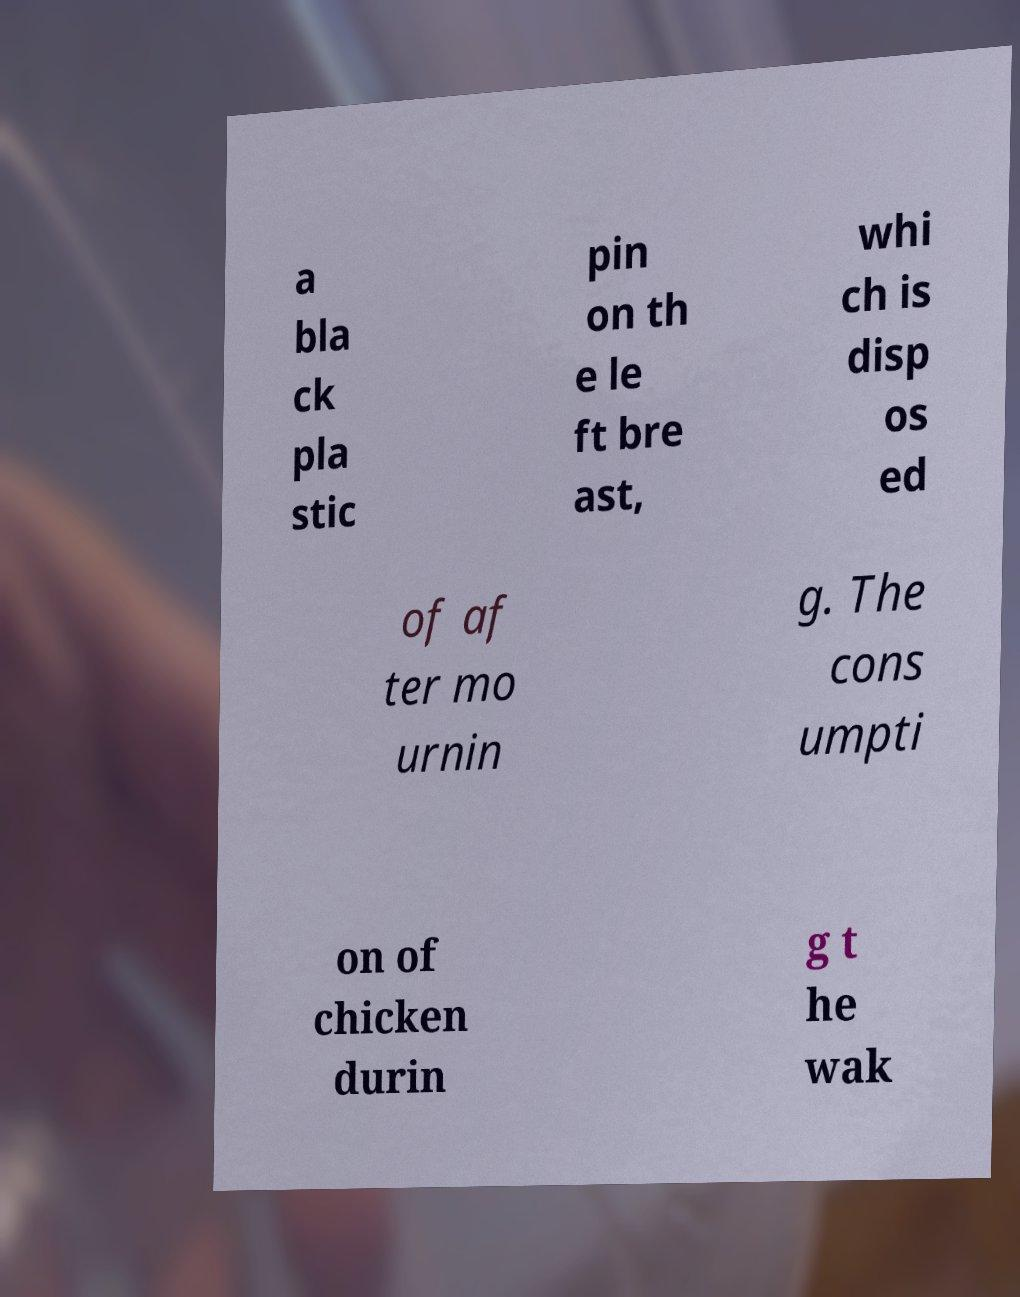Could you assist in decoding the text presented in this image and type it out clearly? a bla ck pla stic pin on th e le ft bre ast, whi ch is disp os ed of af ter mo urnin g. The cons umpti on of chicken durin g t he wak 